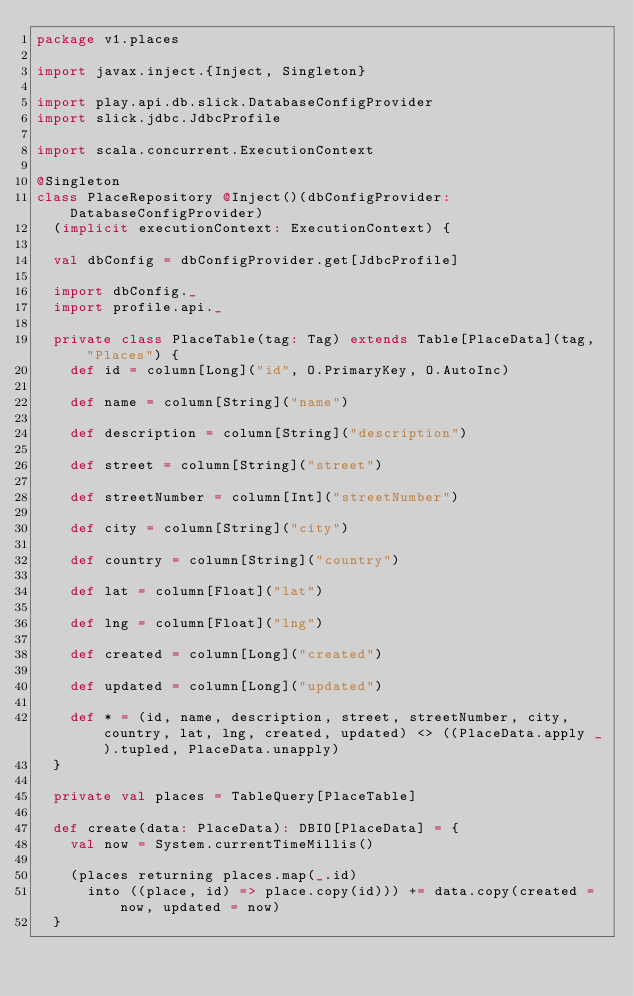<code> <loc_0><loc_0><loc_500><loc_500><_Scala_>package v1.places

import javax.inject.{Inject, Singleton}

import play.api.db.slick.DatabaseConfigProvider
import slick.jdbc.JdbcProfile

import scala.concurrent.ExecutionContext

@Singleton
class PlaceRepository @Inject()(dbConfigProvider: DatabaseConfigProvider)
  (implicit executionContext: ExecutionContext) {

  val dbConfig = dbConfigProvider.get[JdbcProfile]

  import dbConfig._
  import profile.api._

  private class PlaceTable(tag: Tag) extends Table[PlaceData](tag, "Places") {
    def id = column[Long]("id", O.PrimaryKey, O.AutoInc)

    def name = column[String]("name")

    def description = column[String]("description")

    def street = column[String]("street")

    def streetNumber = column[Int]("streetNumber")

    def city = column[String]("city")

    def country = column[String]("country")

    def lat = column[Float]("lat")

    def lng = column[Float]("lng")

    def created = column[Long]("created")

    def updated = column[Long]("updated")

    def * = (id, name, description, street, streetNumber, city, country, lat, lng, created, updated) <> ((PlaceData.apply _).tupled, PlaceData.unapply)
  }

  private val places = TableQuery[PlaceTable]

  def create(data: PlaceData): DBIO[PlaceData] = {
    val now = System.currentTimeMillis()

    (places returning places.map(_.id)
      into ((place, id) => place.copy(id))) += data.copy(created = now, updated = now)
  }
</code> 